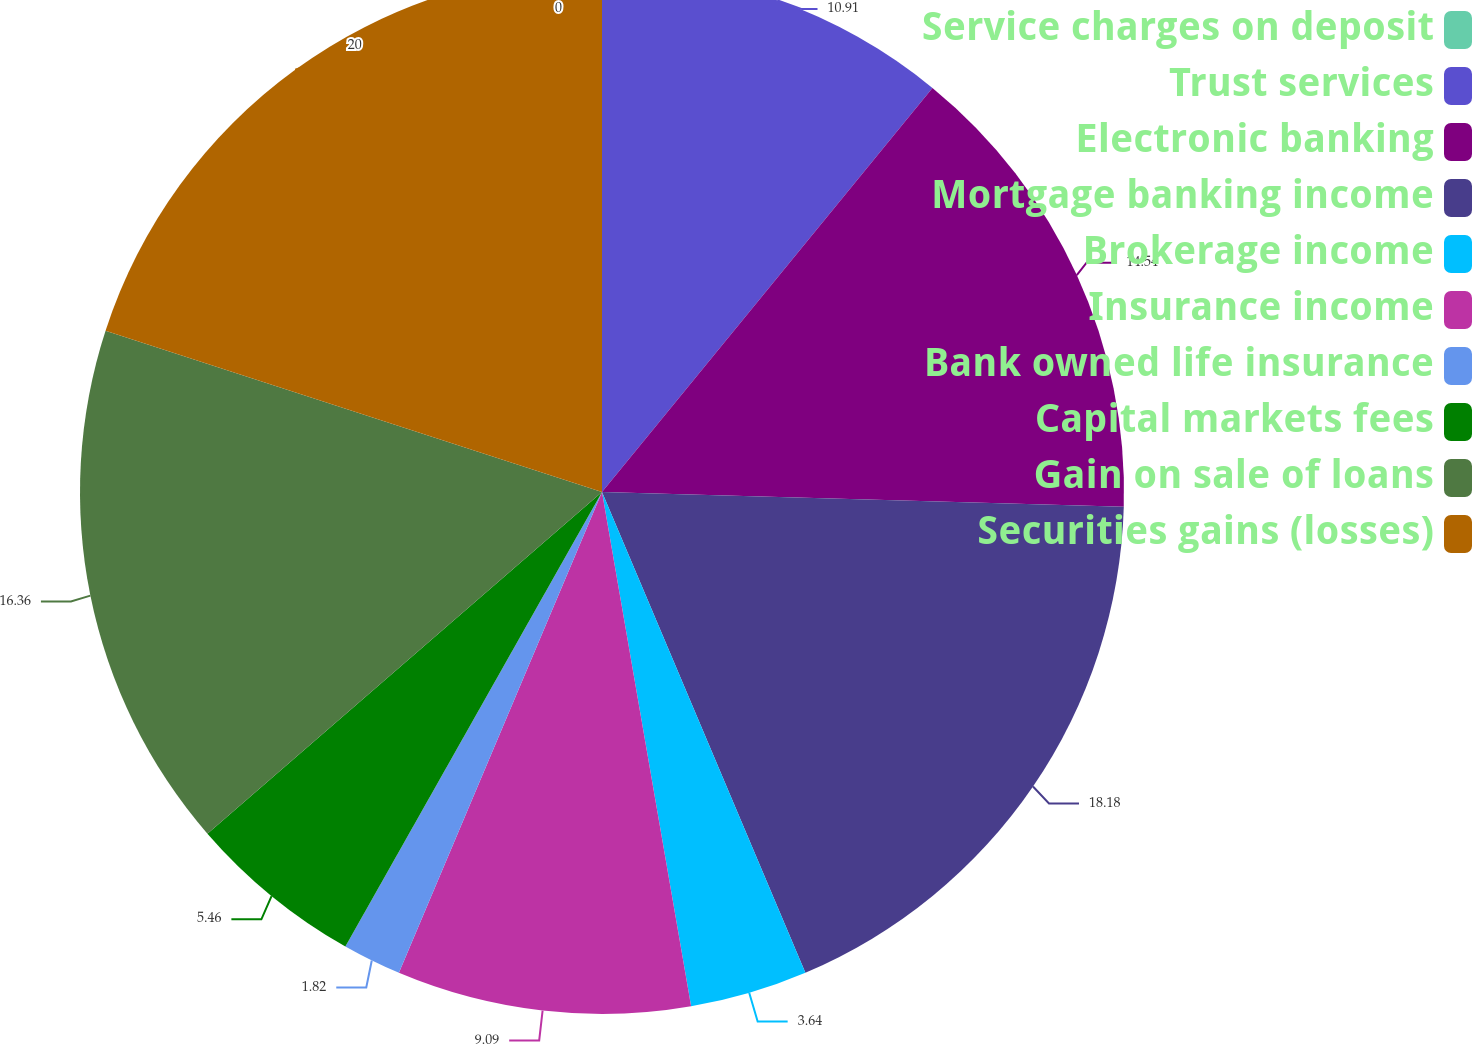Convert chart to OTSL. <chart><loc_0><loc_0><loc_500><loc_500><pie_chart><fcel>Service charges on deposit<fcel>Trust services<fcel>Electronic banking<fcel>Mortgage banking income<fcel>Brokerage income<fcel>Insurance income<fcel>Bank owned life insurance<fcel>Capital markets fees<fcel>Gain on sale of loans<fcel>Securities gains (losses)<nl><fcel>0.0%<fcel>10.91%<fcel>14.54%<fcel>18.18%<fcel>3.64%<fcel>9.09%<fcel>1.82%<fcel>5.46%<fcel>16.36%<fcel>20.0%<nl></chart> 